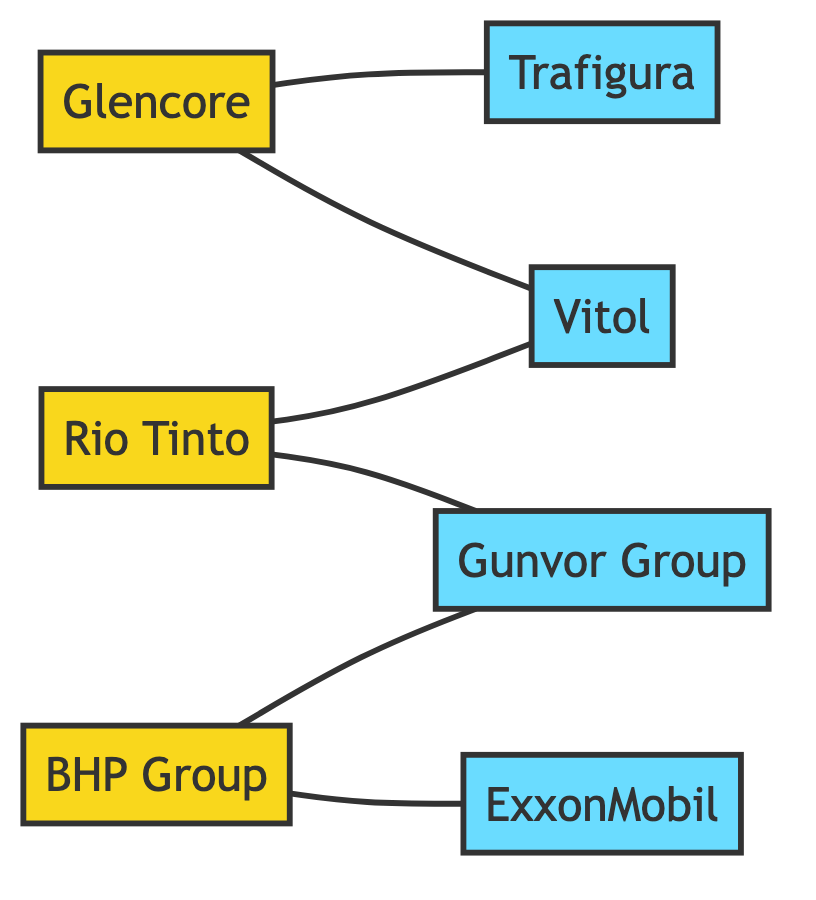What is the total number of nodes in the graph? The nodes in the graph are Glencore, Rio Tinto, BHP Group, Trafigura, Vitol, Gunvor Group, and ExxonMobil. By counting these, there are a total of 7 nodes.
Answer: 7 How many suppliers are represented in the diagram? By identifying the nodes in the graph, Glencore, Rio Tinto, and BHP Group are classified as suppliers. There are 3 suppliers in the diagram.
Answer: 3 Which distributor is connected to Glencore? Reviewing the edges connected to Glencore, we see that there are connections to Trafigura and Vitol. Both are distributors linked to Glencore.
Answer: Trafigura, Vitol What is the maximum number of distributors connected to any single supplier? Evaluating each supplier's connections: Glencore connects to 2 distributors, Rio Tinto connects to 2 distributors, and BHP Group connects to 2 distributors as well. The maximum is thus 2.
Answer: 2 How many edges are present in the diagram? Counting the connections from the edges list gives us six direct connections: Glencore to Trafigura, Glencore to Vitol, Rio Tinto to Vitol, Rio Tinto to Gunvor Group, BHP Group to Gunvor Group, and BHP Group to ExxonMobil. This totals 6 edges.
Answer: 6 Which distributor has connections to the highest number of suppliers? Looking at the connections, Vitol is connected to 2 suppliers (Glencore, Rio Tinto), while Trafigura is connected to 1 supplier, Gunvor Group is connected to 2 suppliers, and ExxonMobil is connected to 1 supplier. Since Vitol and Gunvor Group both connect to 2 suppliers, they are tied.
Answer: Vitol, Gunvor Group Are there any suppliers that connect to all distributors in the diagram? Analyzing the connections, Glencore connects to 2 distributors, Rio Tinto connects to 2 distributors, and BHP Group connects to 2 distributors as well. No supplier connects to all distributors, which totals 4.
Answer: No Which supplier has the most connections to distributors? Checking the connections, Glencore has 2 connections (to Trafigura and Vitol), Rio Tinto has 2 connections (to Vitol and Gunvor Group), and BHP Group also has 2 connections (to Gunvor Group and ExxonMobil). The answer remains consistent at 2 for all suppliers.
Answer: 2 Which suppliers have connections to Gunvor Group? Upon examining the edges, Rio Tinto and BHP Group each have a direct connection to Gunvor Group, thus both are the suppliers connected to it.
Answer: Rio Tinto, BHP Group 